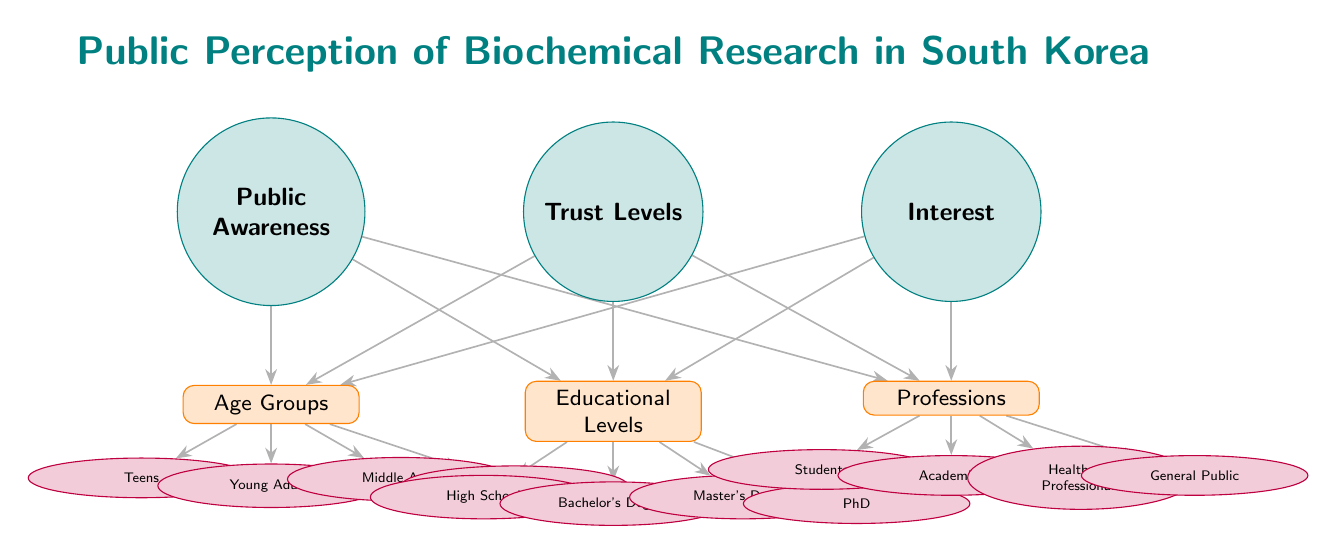What are the three main categories depicted in the diagram? The diagram displays three main categories: Public Awareness, Trust Levels, and Interest. This can be identified by looking at the three main nodes at the top of the diagram.
Answer: Public Awareness, Trust Levels, Interest How many age groups are represented in the diagram? The age groups are listed as Teens, Young Adults, Middle Aged, and Seniors. Counting these sub-nodes shows that there are four distinct age groups represented in the diagram.
Answer: 4 Which profession segment is directly associated with public awareness in the diagram? The profession segments are Students, Academics, Healthcare Professionals, and General Public, which are all connected to the Public Awareness node as sub-nodes. Therefore, all four segments are directly associated with public awareness.
Answer: Students, Academics, Healthcare Professionals, General Public What type of relationship exists between Educational Levels and Interest? The Educational Levels (High School, Bachelor's Degree, Master's Degree, PhD) are connected to Interest with an edge that indicates a direct relationship. Hence, there is a direct connection indicating the relationship.
Answer: Direct relationship Which age group is the youngest demographic represented in the survey? The youngest demographic, as per the age groups represented in the diagram, is Teens. This age group is positioned at the lowest level of the Age Groups sub-node.
Answer: Teens How many total sub-nodes are associated with Trust Levels? There are three sub-nodes associated with Trust Levels: Age Groups, Educational Levels, and Professions. Each of these represents different aspects influencing Trust Levels as indicated by their connections. Counting these gives a total of three sub-nodes.
Answer: 3 Which educational level corresponds to the highest academic achievement in this diagram? The highest academic achievement level depicted in the Educational Levels node is PhD, which is the last sub-node under Educational Levels.
Answer: PhD Why would connections from Age Groups to Interest suggest trends in various demographics? The connections indicate how different age groups (Teens, Young Adults, Middle Aged, Seniors) may have different levels of Interest in biochemical research, suggesting demographic trends based on their awareness and trust. This reasoning stems from analyzing the relationships illustrated in the diagram affecting how interested each age group is in the research.
Answer: Demographic trends 